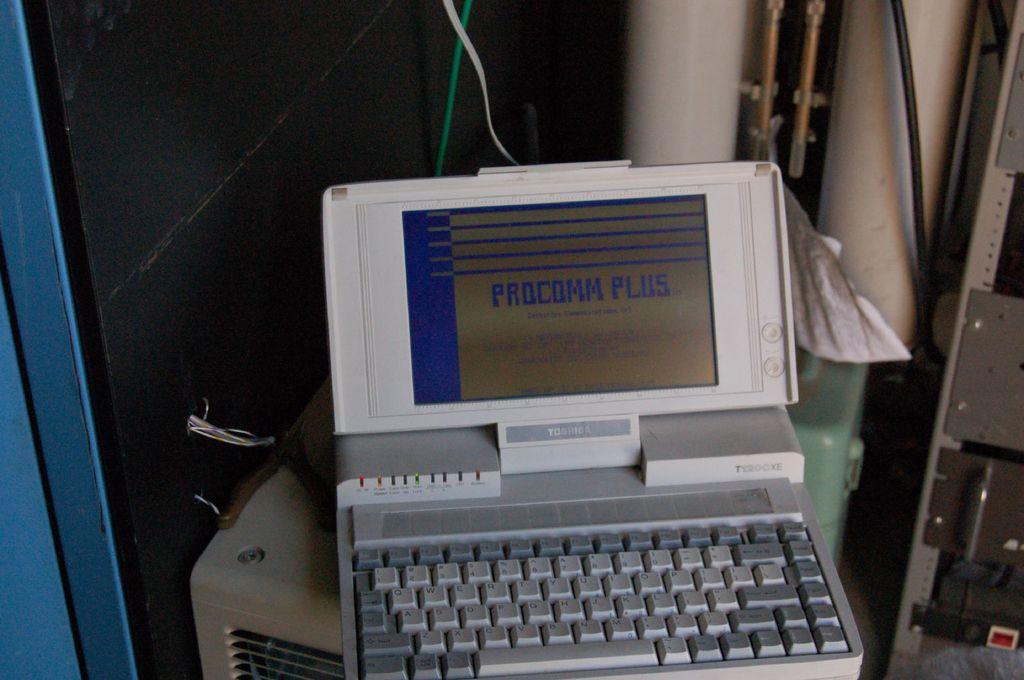What is the name of this computer on the screen?
Give a very brief answer. Procomm plus. What brand is the computer?
Offer a terse response. Toshiba. 